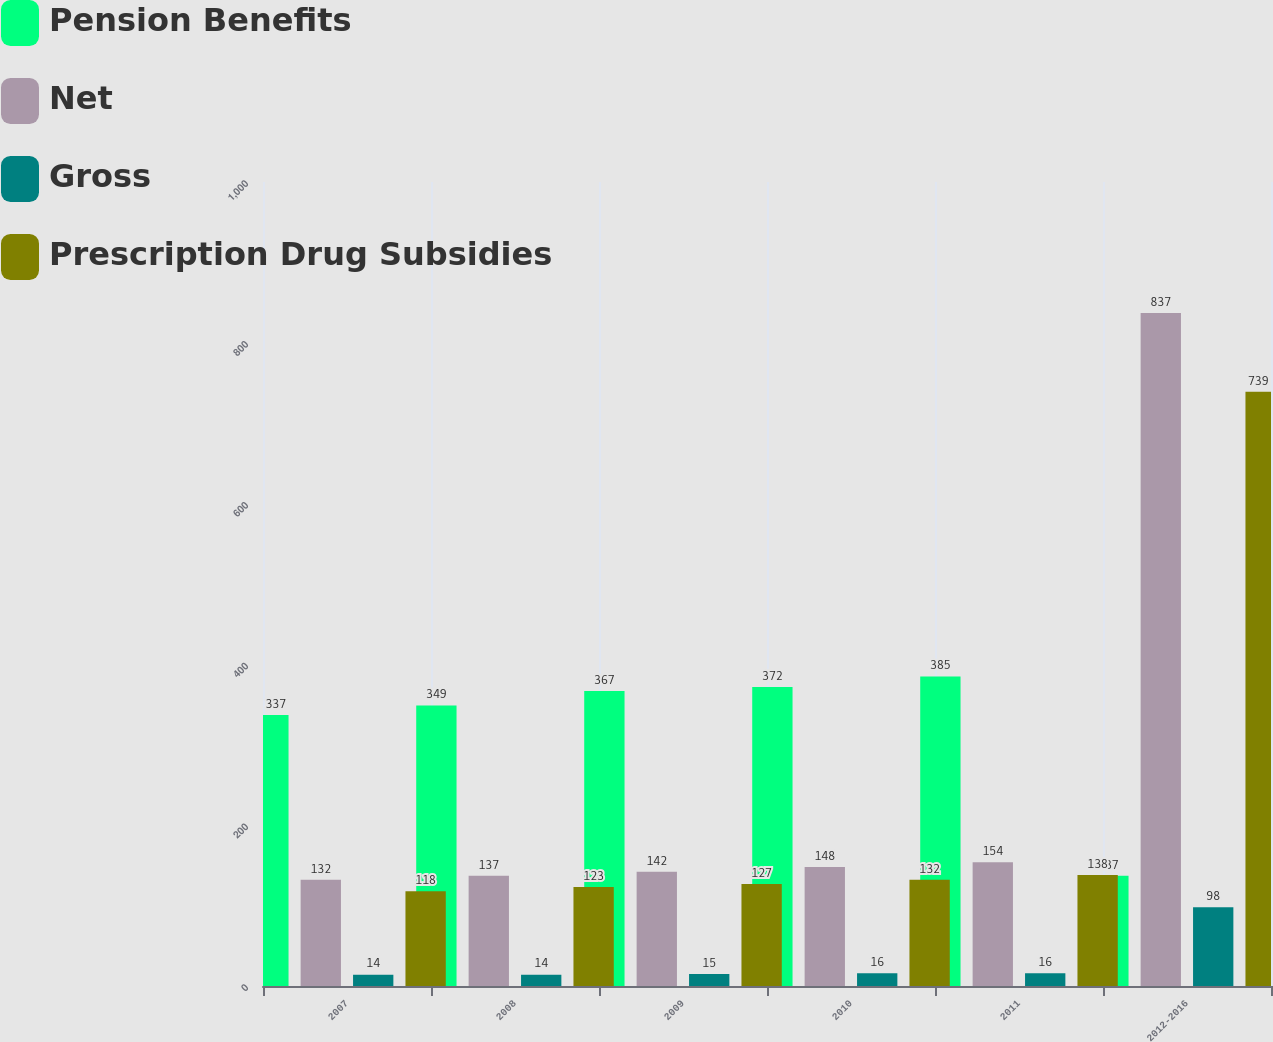<chart> <loc_0><loc_0><loc_500><loc_500><stacked_bar_chart><ecel><fcel>2007<fcel>2008<fcel>2009<fcel>2010<fcel>2011<fcel>2012-2016<nl><fcel>Pension Benefits<fcel>337<fcel>349<fcel>367<fcel>372<fcel>385<fcel>137<nl><fcel>Net<fcel>132<fcel>137<fcel>142<fcel>148<fcel>154<fcel>837<nl><fcel>Gross<fcel>14<fcel>14<fcel>15<fcel>16<fcel>16<fcel>98<nl><fcel>Prescription Drug Subsidies<fcel>118<fcel>123<fcel>127<fcel>132<fcel>138<fcel>739<nl></chart> 